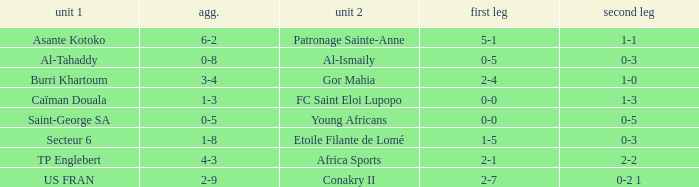What was the 2nd leg score between Patronage Sainte-Anne and Asante Kotoko? 1-1. 